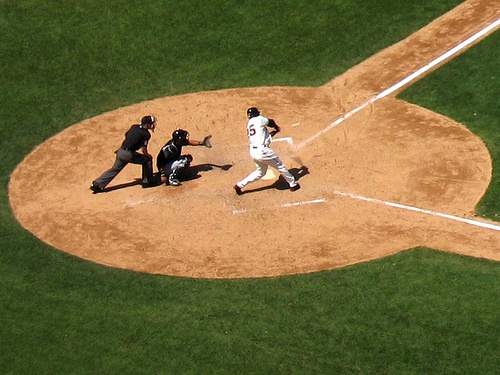Describe the objects in this image and their specific colors. I can see people in darkgreen, black, tan, gray, and maroon tones, people in darkgreen, white, gray, black, and darkgray tones, people in darkgreen, black, gray, maroon, and tan tones, baseball glove in darkgreen, maroon, and gray tones, and baseball bat in darkgreen, black, maroon, and brown tones in this image. 